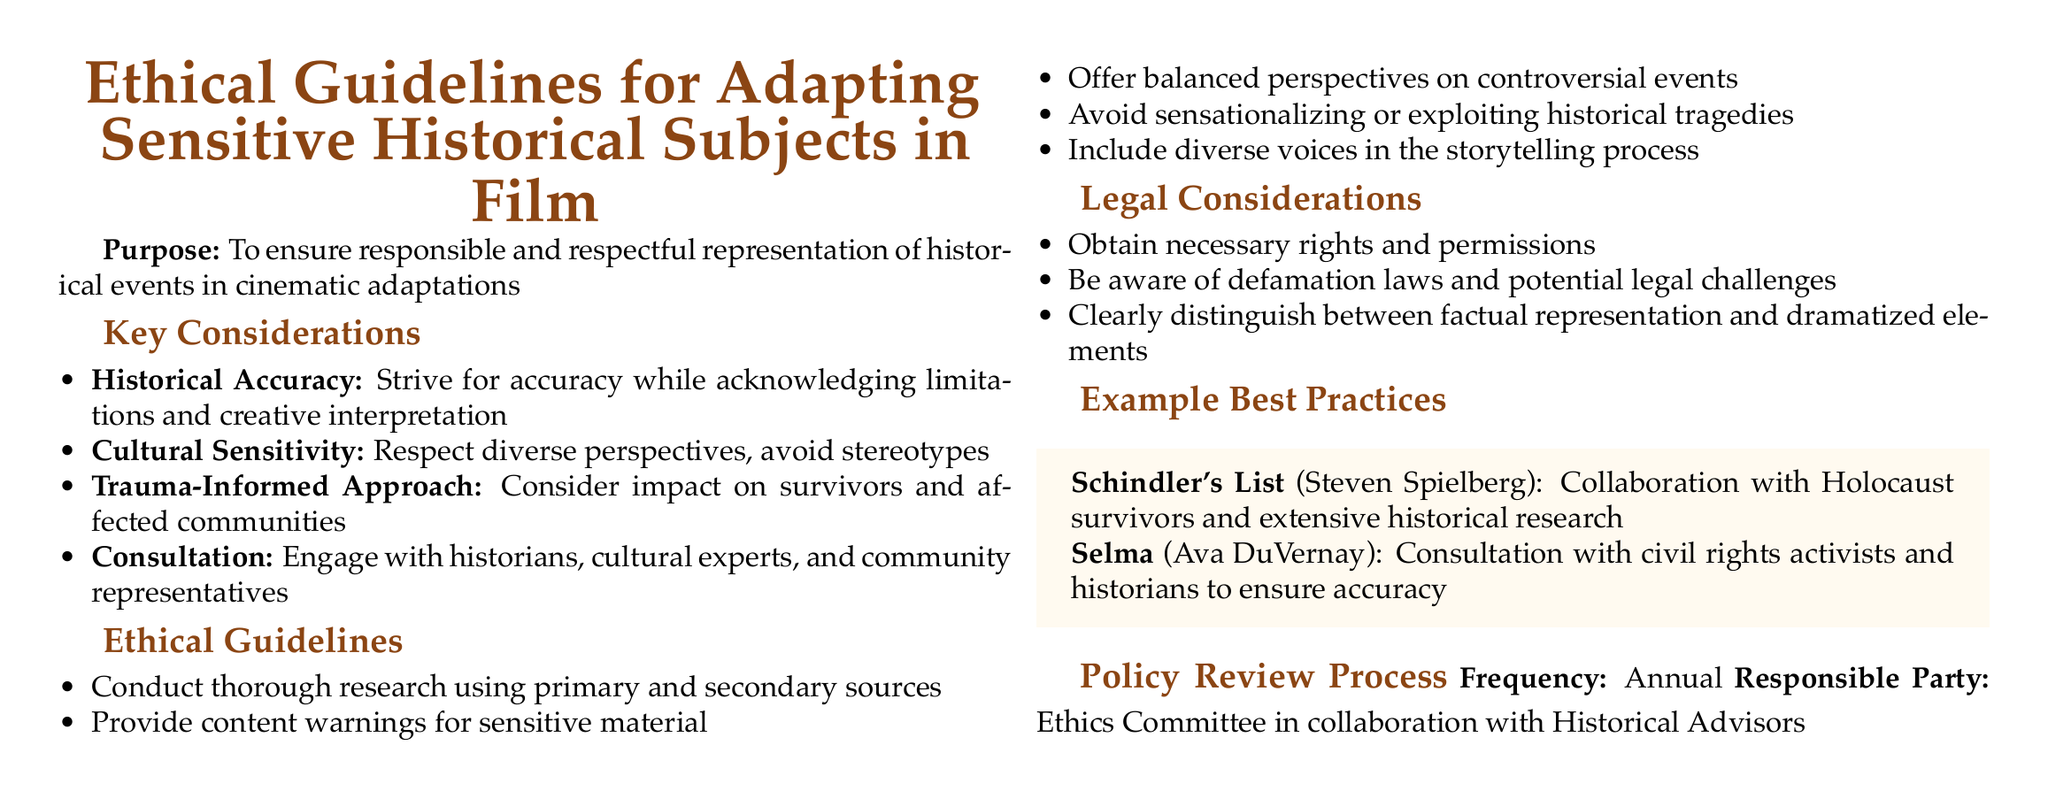What is the purpose of the guidelines? The purpose of the guidelines is to ensure responsible and respectful representation of historical events in cinematic adaptations.
Answer: To ensure responsible and respectful representation of historical events in cinematic adaptations How frequently is the policy reviewed? The document states that the policy review process occurs annually.
Answer: Annual Who is responsible for the policy review? The document indicates that the Ethics Committee in collaboration with Historical Advisors is responsible for the policy review.
Answer: Ethics Committee in collaboration with Historical Advisors Name a film mentioned as an example of best practices. The document provides "Schindler's List" and "Selma" as examples of best practices in adapting sensitive historical subjects.
Answer: Schindler's List What approach should be taken towards the representation of trauma? The document emphasizes a trauma-informed approach to consider the impact on survivors and affected communities.
Answer: Trauma-Informed Approach What is a key guideline regarding research? The document requires conducting thorough research using primary and secondary sources as a key guideline.
Answer: Conduct thorough research using primary and secondary sources What does the document encourage regarding diverse voices? It encourages including diverse voices in the storytelling process when adapting historical subjects.
Answer: Include diverse voices in the storytelling process What should be provided for sensitive material? The guideline mentions providing content warnings for sensitive material.
Answer: Content warnings 